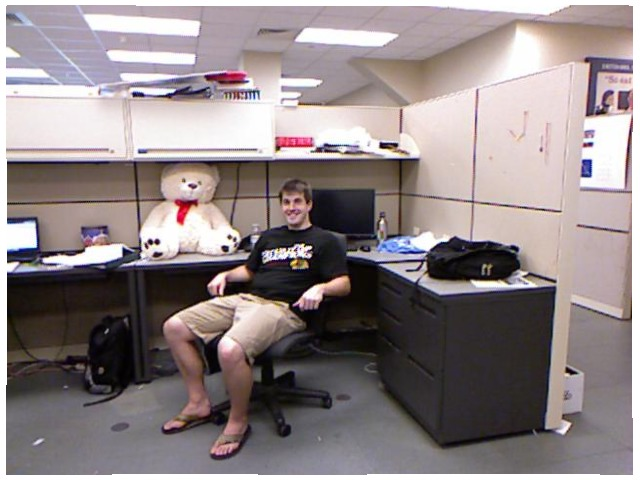<image>
Is the bag under the table? Yes. The bag is positioned underneath the table, with the table above it in the vertical space. Is there a bow on the bear? Yes. Looking at the image, I can see the bow is positioned on top of the bear, with the bear providing support. Where is the bear in relation to the table? Is it on the table? Yes. Looking at the image, I can see the bear is positioned on top of the table, with the table providing support. Is there a teddy bear on the man? No. The teddy bear is not positioned on the man. They may be near each other, but the teddy bear is not supported by or resting on top of the man. Where is the bear in relation to the man? Is it behind the man? Yes. From this viewpoint, the bear is positioned behind the man, with the man partially or fully occluding the bear. Is there a teddy bear next to the guy? Yes. The teddy bear is positioned adjacent to the guy, located nearby in the same general area. 